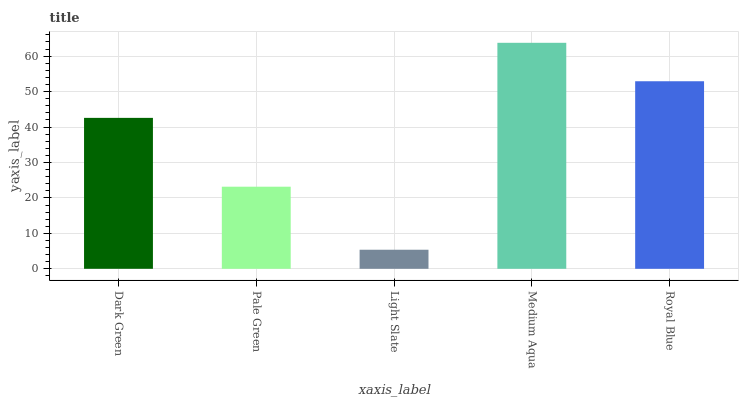Is Light Slate the minimum?
Answer yes or no. Yes. Is Medium Aqua the maximum?
Answer yes or no. Yes. Is Pale Green the minimum?
Answer yes or no. No. Is Pale Green the maximum?
Answer yes or no. No. Is Dark Green greater than Pale Green?
Answer yes or no. Yes. Is Pale Green less than Dark Green?
Answer yes or no. Yes. Is Pale Green greater than Dark Green?
Answer yes or no. No. Is Dark Green less than Pale Green?
Answer yes or no. No. Is Dark Green the high median?
Answer yes or no. Yes. Is Dark Green the low median?
Answer yes or no. Yes. Is Light Slate the high median?
Answer yes or no. No. Is Royal Blue the low median?
Answer yes or no. No. 